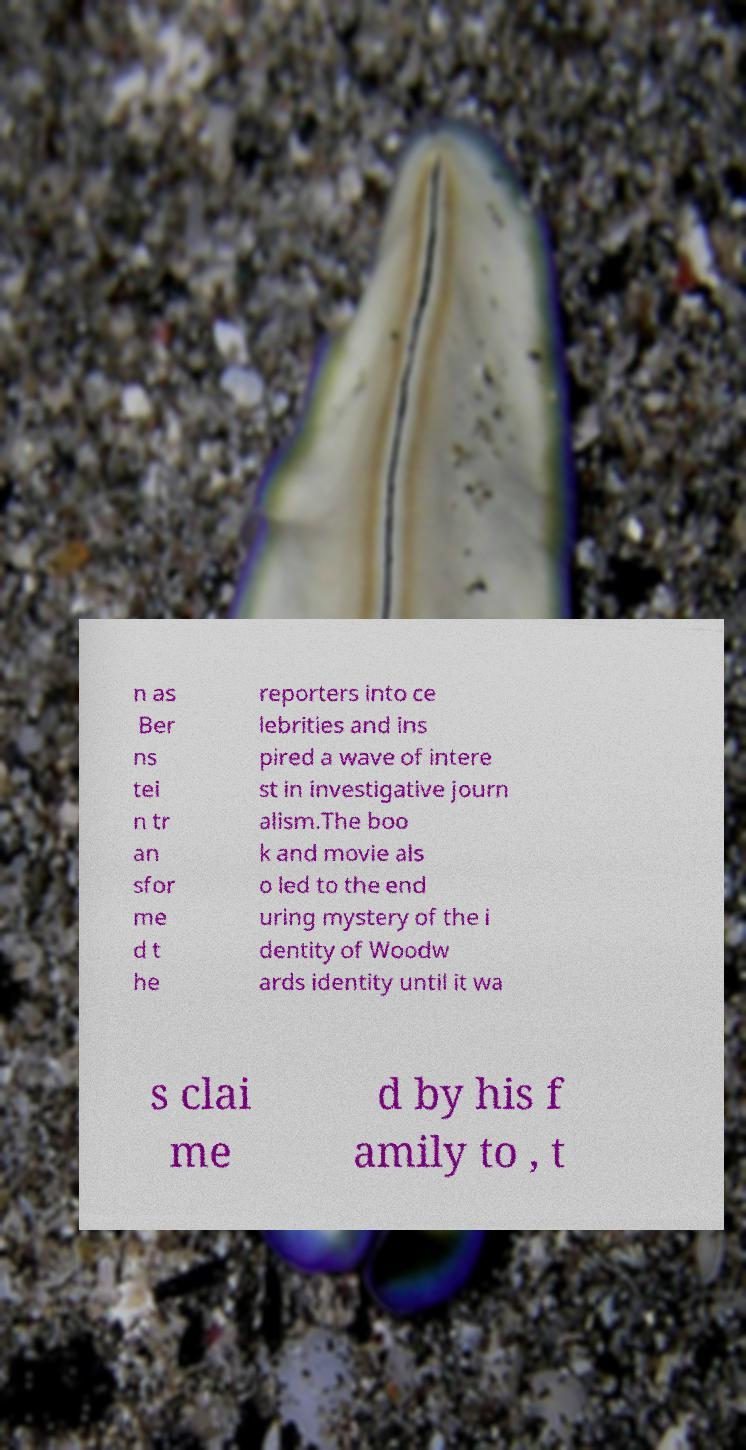I need the written content from this picture converted into text. Can you do that? n as Ber ns tei n tr an sfor me d t he reporters into ce lebrities and ins pired a wave of intere st in investigative journ alism.The boo k and movie als o led to the end uring mystery of the i dentity of Woodw ards identity until it wa s clai me d by his f amily to , t 